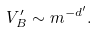Convert formula to latex. <formula><loc_0><loc_0><loc_500><loc_500>V _ { B } ^ { \prime } \sim m ^ { - d ^ { \prime } } .</formula> 